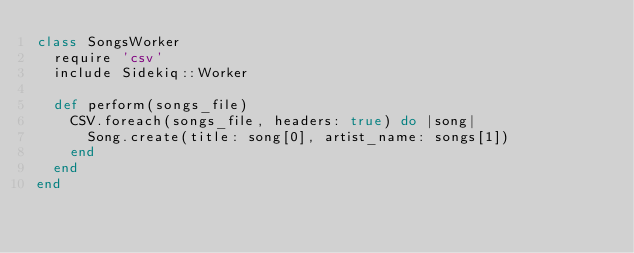<code> <loc_0><loc_0><loc_500><loc_500><_Ruby_>class SongsWorker
  require 'csv'
  include Sidekiq::Worker

  def perform(songs_file)
    CSV.foreach(songs_file, headers: true) do |song|
      Song.create(title: song[0], artist_name: songs[1])
    end
  end
end
</code> 